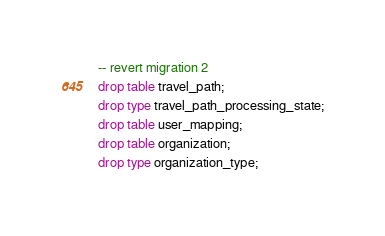Convert code to text. <code><loc_0><loc_0><loc_500><loc_500><_SQL_>-- revert migration 2
drop table travel_path;
drop type travel_path_processing_state;
drop table user_mapping;
drop table organization;
drop type organization_type;
</code> 